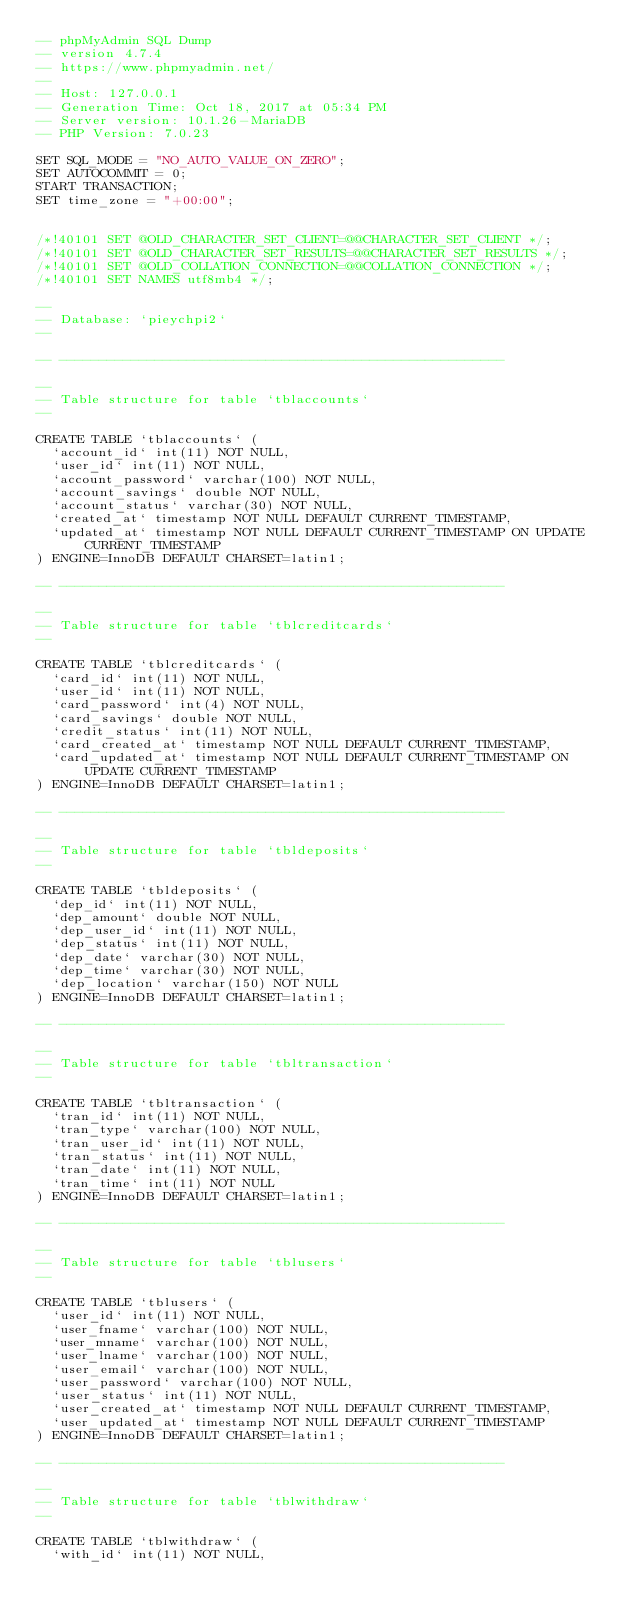Convert code to text. <code><loc_0><loc_0><loc_500><loc_500><_SQL_>-- phpMyAdmin SQL Dump
-- version 4.7.4
-- https://www.phpmyadmin.net/
--
-- Host: 127.0.0.1
-- Generation Time: Oct 18, 2017 at 05:34 PM
-- Server version: 10.1.26-MariaDB
-- PHP Version: 7.0.23

SET SQL_MODE = "NO_AUTO_VALUE_ON_ZERO";
SET AUTOCOMMIT = 0;
START TRANSACTION;
SET time_zone = "+00:00";


/*!40101 SET @OLD_CHARACTER_SET_CLIENT=@@CHARACTER_SET_CLIENT */;
/*!40101 SET @OLD_CHARACTER_SET_RESULTS=@@CHARACTER_SET_RESULTS */;
/*!40101 SET @OLD_COLLATION_CONNECTION=@@COLLATION_CONNECTION */;
/*!40101 SET NAMES utf8mb4 */;

--
-- Database: `pieychpi2`
--

-- --------------------------------------------------------

--
-- Table structure for table `tblaccounts`
--

CREATE TABLE `tblaccounts` (
  `account_id` int(11) NOT NULL,
  `user_id` int(11) NOT NULL,
  `account_password` varchar(100) NOT NULL,
  `account_savings` double NOT NULL,
  `account_status` varchar(30) NOT NULL,
  `created_at` timestamp NOT NULL DEFAULT CURRENT_TIMESTAMP,
  `updated_at` timestamp NOT NULL DEFAULT CURRENT_TIMESTAMP ON UPDATE CURRENT_TIMESTAMP
) ENGINE=InnoDB DEFAULT CHARSET=latin1;

-- --------------------------------------------------------

--
-- Table structure for table `tblcreditcards`
--

CREATE TABLE `tblcreditcards` (
  `card_id` int(11) NOT NULL,
  `user_id` int(11) NOT NULL,
  `card_password` int(4) NOT NULL,
  `card_savings` double NOT NULL,
  `credit_status` int(11) NOT NULL,
  `card_created_at` timestamp NOT NULL DEFAULT CURRENT_TIMESTAMP,
  `card_updated_at` timestamp NOT NULL DEFAULT CURRENT_TIMESTAMP ON UPDATE CURRENT_TIMESTAMP
) ENGINE=InnoDB DEFAULT CHARSET=latin1;

-- --------------------------------------------------------

--
-- Table structure for table `tbldeposits`
--

CREATE TABLE `tbldeposits` (
  `dep_id` int(11) NOT NULL,
  `dep_amount` double NOT NULL,
  `dep_user_id` int(11) NOT NULL,
  `dep_status` int(11) NOT NULL,
  `dep_date` varchar(30) NOT NULL,
  `dep_time` varchar(30) NOT NULL,
  `dep_location` varchar(150) NOT NULL
) ENGINE=InnoDB DEFAULT CHARSET=latin1;

-- --------------------------------------------------------

--
-- Table structure for table `tbltransaction`
--

CREATE TABLE `tbltransaction` (
  `tran_id` int(11) NOT NULL,
  `tran_type` varchar(100) NOT NULL,
  `tran_user_id` int(11) NOT NULL,
  `tran_status` int(11) NOT NULL,
  `tran_date` int(11) NOT NULL,
  `tran_time` int(11) NOT NULL
) ENGINE=InnoDB DEFAULT CHARSET=latin1;

-- --------------------------------------------------------

--
-- Table structure for table `tblusers`
--

CREATE TABLE `tblusers` (
  `user_id` int(11) NOT NULL,
  `user_fname` varchar(100) NOT NULL,
  `user_mname` varchar(100) NOT NULL,
  `user_lname` varchar(100) NOT NULL,
  `user_email` varchar(100) NOT NULL,
  `user_password` varchar(100) NOT NULL,
  `user_status` int(11) NOT NULL,
  `user_created_at` timestamp NOT NULL DEFAULT CURRENT_TIMESTAMP,
  `user_updated_at` timestamp NOT NULL DEFAULT CURRENT_TIMESTAMP
) ENGINE=InnoDB DEFAULT CHARSET=latin1;

-- --------------------------------------------------------

--
-- Table structure for table `tblwithdraw`
--

CREATE TABLE `tblwithdraw` (
  `with_id` int(11) NOT NULL,</code> 